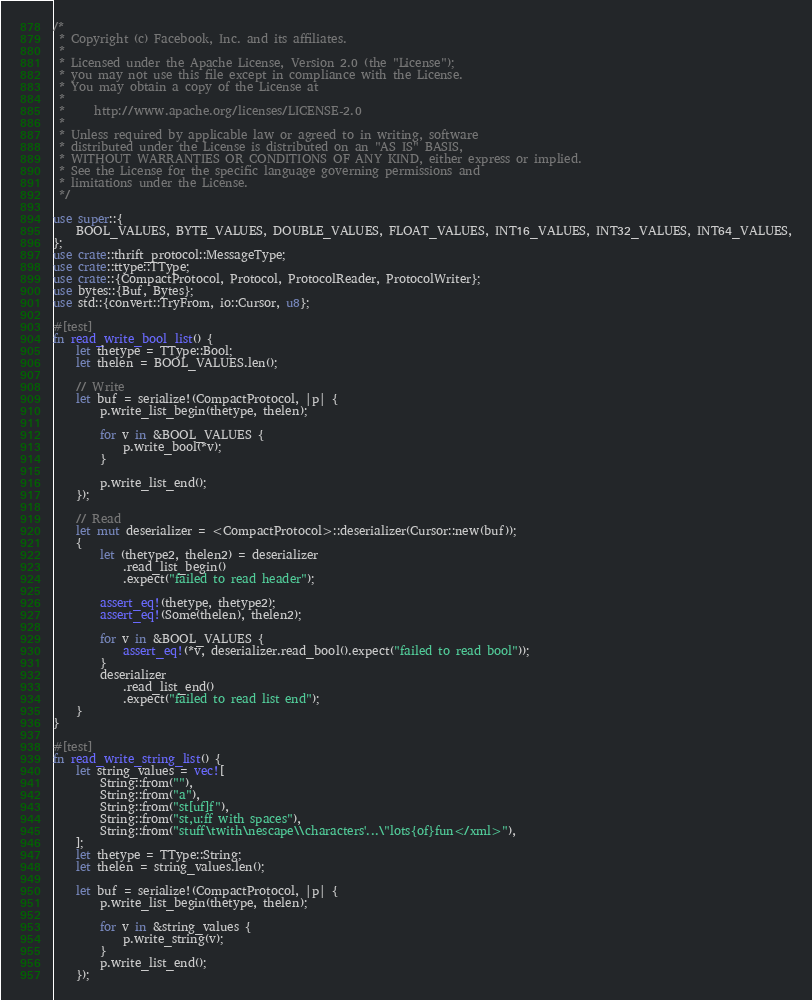<code> <loc_0><loc_0><loc_500><loc_500><_Rust_>/*
 * Copyright (c) Facebook, Inc. and its affiliates.
 *
 * Licensed under the Apache License, Version 2.0 (the "License");
 * you may not use this file except in compliance with the License.
 * You may obtain a copy of the License at
 *
 *     http://www.apache.org/licenses/LICENSE-2.0
 *
 * Unless required by applicable law or agreed to in writing, software
 * distributed under the License is distributed on an "AS IS" BASIS,
 * WITHOUT WARRANTIES OR CONDITIONS OF ANY KIND, either express or implied.
 * See the License for the specific language governing permissions and
 * limitations under the License.
 */

use super::{
    BOOL_VALUES, BYTE_VALUES, DOUBLE_VALUES, FLOAT_VALUES, INT16_VALUES, INT32_VALUES, INT64_VALUES,
};
use crate::thrift_protocol::MessageType;
use crate::ttype::TType;
use crate::{CompactProtocol, Protocol, ProtocolReader, ProtocolWriter};
use bytes::{Buf, Bytes};
use std::{convert::TryFrom, io::Cursor, u8};

#[test]
fn read_write_bool_list() {
    let thetype = TType::Bool;
    let thelen = BOOL_VALUES.len();

    // Write
    let buf = serialize!(CompactProtocol, |p| {
        p.write_list_begin(thetype, thelen);

        for v in &BOOL_VALUES {
            p.write_bool(*v);
        }

        p.write_list_end();
    });

    // Read
    let mut deserializer = <CompactProtocol>::deserializer(Cursor::new(buf));
    {
        let (thetype2, thelen2) = deserializer
            .read_list_begin()
            .expect("failed to read header");

        assert_eq!(thetype, thetype2);
        assert_eq!(Some(thelen), thelen2);

        for v in &BOOL_VALUES {
            assert_eq!(*v, deserializer.read_bool().expect("failed to read bool"));
        }
        deserializer
            .read_list_end()
            .expect("failed to read list end");
    }
}

#[test]
fn read_write_string_list() {
    let string_values = vec![
        String::from(""),
        String::from("a"),
        String::from("st[uf]f"),
        String::from("st,u:ff with spaces"),
        String::from("stuff\twith\nescape\\characters'...\"lots{of}fun</xml>"),
    ];
    let thetype = TType::String;
    let thelen = string_values.len();

    let buf = serialize!(CompactProtocol, |p| {
        p.write_list_begin(thetype, thelen);

        for v in &string_values {
            p.write_string(v);
        }
        p.write_list_end();
    });
</code> 